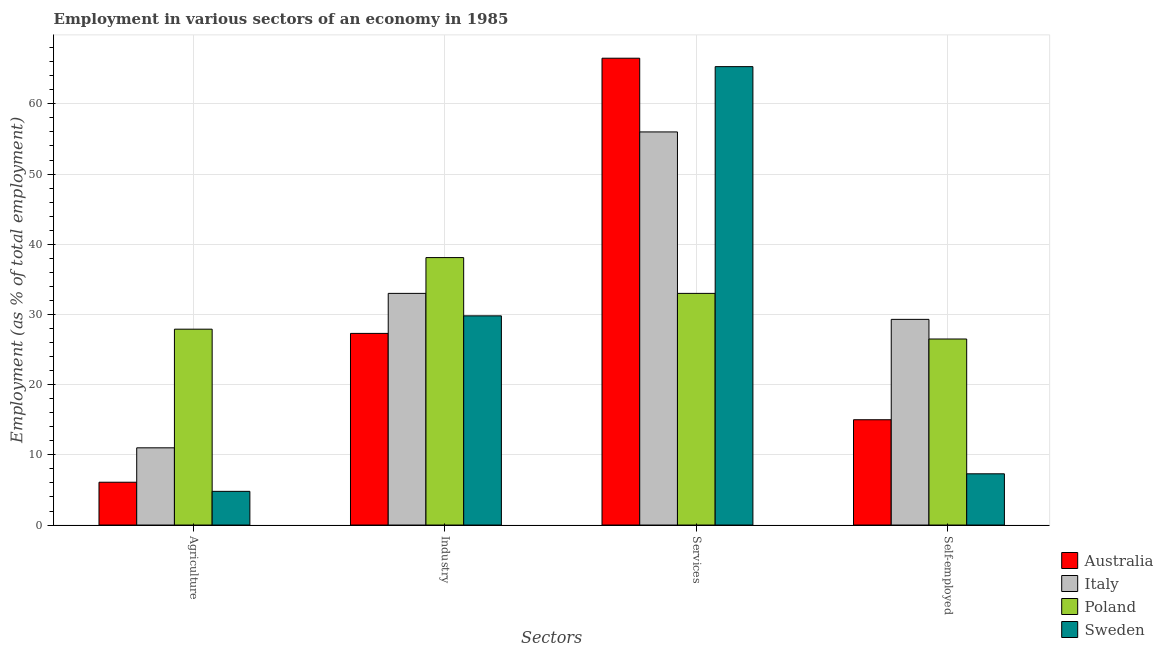How many bars are there on the 1st tick from the left?
Your answer should be compact. 4. How many bars are there on the 2nd tick from the right?
Your answer should be compact. 4. What is the label of the 4th group of bars from the left?
Give a very brief answer. Self-employed. What is the percentage of workers in services in Sweden?
Make the answer very short. 65.3. Across all countries, what is the maximum percentage of workers in industry?
Ensure brevity in your answer.  38.1. Across all countries, what is the minimum percentage of workers in industry?
Provide a short and direct response. 27.3. In which country was the percentage of workers in industry minimum?
Keep it short and to the point. Australia. What is the total percentage of workers in services in the graph?
Ensure brevity in your answer.  220.8. What is the difference between the percentage of workers in services in Australia and that in Sweden?
Make the answer very short. 1.2. What is the difference between the percentage of workers in agriculture in Poland and the percentage of self employed workers in Australia?
Keep it short and to the point. 12.9. What is the average percentage of workers in industry per country?
Ensure brevity in your answer.  32.05. What is the difference between the percentage of self employed workers and percentage of workers in agriculture in Italy?
Your answer should be compact. 18.3. In how many countries, is the percentage of workers in industry greater than 64 %?
Offer a terse response. 0. What is the ratio of the percentage of self employed workers in Sweden to that in Australia?
Keep it short and to the point. 0.49. Is the percentage of workers in agriculture in Australia less than that in Poland?
Your response must be concise. Yes. Is the difference between the percentage of workers in services in Italy and Australia greater than the difference between the percentage of workers in agriculture in Italy and Australia?
Offer a terse response. No. What is the difference between the highest and the second highest percentage of workers in industry?
Make the answer very short. 5.1. What is the difference between the highest and the lowest percentage of workers in industry?
Your response must be concise. 10.8. Is the sum of the percentage of workers in services in Sweden and Australia greater than the maximum percentage of workers in agriculture across all countries?
Your response must be concise. Yes. What does the 4th bar from the right in Agriculture represents?
Your response must be concise. Australia. Is it the case that in every country, the sum of the percentage of workers in agriculture and percentage of workers in industry is greater than the percentage of workers in services?
Provide a succinct answer. No. How many bars are there?
Your answer should be compact. 16. Are all the bars in the graph horizontal?
Provide a short and direct response. No. How many countries are there in the graph?
Keep it short and to the point. 4. Does the graph contain grids?
Provide a succinct answer. Yes. How are the legend labels stacked?
Your response must be concise. Vertical. What is the title of the graph?
Offer a very short reply. Employment in various sectors of an economy in 1985. Does "Cote d'Ivoire" appear as one of the legend labels in the graph?
Provide a succinct answer. No. What is the label or title of the X-axis?
Your answer should be very brief. Sectors. What is the label or title of the Y-axis?
Your response must be concise. Employment (as % of total employment). What is the Employment (as % of total employment) of Australia in Agriculture?
Ensure brevity in your answer.  6.1. What is the Employment (as % of total employment) in Italy in Agriculture?
Ensure brevity in your answer.  11. What is the Employment (as % of total employment) of Poland in Agriculture?
Make the answer very short. 27.9. What is the Employment (as % of total employment) of Sweden in Agriculture?
Provide a short and direct response. 4.8. What is the Employment (as % of total employment) of Australia in Industry?
Your answer should be compact. 27.3. What is the Employment (as % of total employment) in Italy in Industry?
Provide a short and direct response. 33. What is the Employment (as % of total employment) in Poland in Industry?
Give a very brief answer. 38.1. What is the Employment (as % of total employment) of Sweden in Industry?
Make the answer very short. 29.8. What is the Employment (as % of total employment) of Australia in Services?
Provide a succinct answer. 66.5. What is the Employment (as % of total employment) of Italy in Services?
Offer a terse response. 56. What is the Employment (as % of total employment) of Sweden in Services?
Provide a succinct answer. 65.3. What is the Employment (as % of total employment) in Australia in Self-employed?
Provide a short and direct response. 15. What is the Employment (as % of total employment) of Italy in Self-employed?
Ensure brevity in your answer.  29.3. What is the Employment (as % of total employment) of Sweden in Self-employed?
Provide a short and direct response. 7.3. Across all Sectors, what is the maximum Employment (as % of total employment) in Australia?
Your answer should be very brief. 66.5. Across all Sectors, what is the maximum Employment (as % of total employment) of Poland?
Offer a very short reply. 38.1. Across all Sectors, what is the maximum Employment (as % of total employment) in Sweden?
Offer a very short reply. 65.3. Across all Sectors, what is the minimum Employment (as % of total employment) in Australia?
Provide a short and direct response. 6.1. Across all Sectors, what is the minimum Employment (as % of total employment) of Sweden?
Your answer should be compact. 4.8. What is the total Employment (as % of total employment) of Australia in the graph?
Offer a very short reply. 114.9. What is the total Employment (as % of total employment) of Italy in the graph?
Your answer should be very brief. 129.3. What is the total Employment (as % of total employment) in Poland in the graph?
Give a very brief answer. 125.5. What is the total Employment (as % of total employment) of Sweden in the graph?
Provide a short and direct response. 107.2. What is the difference between the Employment (as % of total employment) of Australia in Agriculture and that in Industry?
Provide a succinct answer. -21.2. What is the difference between the Employment (as % of total employment) of Sweden in Agriculture and that in Industry?
Give a very brief answer. -25. What is the difference between the Employment (as % of total employment) of Australia in Agriculture and that in Services?
Your answer should be compact. -60.4. What is the difference between the Employment (as % of total employment) in Italy in Agriculture and that in Services?
Provide a short and direct response. -45. What is the difference between the Employment (as % of total employment) in Poland in Agriculture and that in Services?
Offer a terse response. -5.1. What is the difference between the Employment (as % of total employment) in Sweden in Agriculture and that in Services?
Make the answer very short. -60.5. What is the difference between the Employment (as % of total employment) in Australia in Agriculture and that in Self-employed?
Provide a short and direct response. -8.9. What is the difference between the Employment (as % of total employment) of Italy in Agriculture and that in Self-employed?
Offer a very short reply. -18.3. What is the difference between the Employment (as % of total employment) in Australia in Industry and that in Services?
Your answer should be compact. -39.2. What is the difference between the Employment (as % of total employment) in Italy in Industry and that in Services?
Offer a terse response. -23. What is the difference between the Employment (as % of total employment) of Sweden in Industry and that in Services?
Provide a short and direct response. -35.5. What is the difference between the Employment (as % of total employment) in Australia in Industry and that in Self-employed?
Offer a terse response. 12.3. What is the difference between the Employment (as % of total employment) in Poland in Industry and that in Self-employed?
Provide a succinct answer. 11.6. What is the difference between the Employment (as % of total employment) of Sweden in Industry and that in Self-employed?
Give a very brief answer. 22.5. What is the difference between the Employment (as % of total employment) in Australia in Services and that in Self-employed?
Ensure brevity in your answer.  51.5. What is the difference between the Employment (as % of total employment) in Italy in Services and that in Self-employed?
Give a very brief answer. 26.7. What is the difference between the Employment (as % of total employment) in Australia in Agriculture and the Employment (as % of total employment) in Italy in Industry?
Provide a succinct answer. -26.9. What is the difference between the Employment (as % of total employment) of Australia in Agriculture and the Employment (as % of total employment) of Poland in Industry?
Provide a succinct answer. -32. What is the difference between the Employment (as % of total employment) in Australia in Agriculture and the Employment (as % of total employment) in Sweden in Industry?
Your answer should be compact. -23.7. What is the difference between the Employment (as % of total employment) of Italy in Agriculture and the Employment (as % of total employment) of Poland in Industry?
Provide a short and direct response. -27.1. What is the difference between the Employment (as % of total employment) of Italy in Agriculture and the Employment (as % of total employment) of Sweden in Industry?
Your answer should be very brief. -18.8. What is the difference between the Employment (as % of total employment) of Poland in Agriculture and the Employment (as % of total employment) of Sweden in Industry?
Ensure brevity in your answer.  -1.9. What is the difference between the Employment (as % of total employment) in Australia in Agriculture and the Employment (as % of total employment) in Italy in Services?
Provide a succinct answer. -49.9. What is the difference between the Employment (as % of total employment) in Australia in Agriculture and the Employment (as % of total employment) in Poland in Services?
Offer a terse response. -26.9. What is the difference between the Employment (as % of total employment) in Australia in Agriculture and the Employment (as % of total employment) in Sweden in Services?
Your answer should be compact. -59.2. What is the difference between the Employment (as % of total employment) in Italy in Agriculture and the Employment (as % of total employment) in Sweden in Services?
Offer a very short reply. -54.3. What is the difference between the Employment (as % of total employment) of Poland in Agriculture and the Employment (as % of total employment) of Sweden in Services?
Provide a short and direct response. -37.4. What is the difference between the Employment (as % of total employment) of Australia in Agriculture and the Employment (as % of total employment) of Italy in Self-employed?
Provide a succinct answer. -23.2. What is the difference between the Employment (as % of total employment) of Australia in Agriculture and the Employment (as % of total employment) of Poland in Self-employed?
Keep it short and to the point. -20.4. What is the difference between the Employment (as % of total employment) in Australia in Agriculture and the Employment (as % of total employment) in Sweden in Self-employed?
Provide a succinct answer. -1.2. What is the difference between the Employment (as % of total employment) of Italy in Agriculture and the Employment (as % of total employment) of Poland in Self-employed?
Your answer should be very brief. -15.5. What is the difference between the Employment (as % of total employment) in Poland in Agriculture and the Employment (as % of total employment) in Sweden in Self-employed?
Offer a very short reply. 20.6. What is the difference between the Employment (as % of total employment) in Australia in Industry and the Employment (as % of total employment) in Italy in Services?
Offer a terse response. -28.7. What is the difference between the Employment (as % of total employment) in Australia in Industry and the Employment (as % of total employment) in Sweden in Services?
Ensure brevity in your answer.  -38. What is the difference between the Employment (as % of total employment) in Italy in Industry and the Employment (as % of total employment) in Poland in Services?
Your answer should be very brief. 0. What is the difference between the Employment (as % of total employment) in Italy in Industry and the Employment (as % of total employment) in Sweden in Services?
Offer a terse response. -32.3. What is the difference between the Employment (as % of total employment) of Poland in Industry and the Employment (as % of total employment) of Sweden in Services?
Offer a terse response. -27.2. What is the difference between the Employment (as % of total employment) in Italy in Industry and the Employment (as % of total employment) in Sweden in Self-employed?
Your answer should be compact. 25.7. What is the difference between the Employment (as % of total employment) of Poland in Industry and the Employment (as % of total employment) of Sweden in Self-employed?
Keep it short and to the point. 30.8. What is the difference between the Employment (as % of total employment) in Australia in Services and the Employment (as % of total employment) in Italy in Self-employed?
Your response must be concise. 37.2. What is the difference between the Employment (as % of total employment) of Australia in Services and the Employment (as % of total employment) of Sweden in Self-employed?
Keep it short and to the point. 59.2. What is the difference between the Employment (as % of total employment) of Italy in Services and the Employment (as % of total employment) of Poland in Self-employed?
Offer a terse response. 29.5. What is the difference between the Employment (as % of total employment) of Italy in Services and the Employment (as % of total employment) of Sweden in Self-employed?
Offer a terse response. 48.7. What is the difference between the Employment (as % of total employment) of Poland in Services and the Employment (as % of total employment) of Sweden in Self-employed?
Your response must be concise. 25.7. What is the average Employment (as % of total employment) in Australia per Sectors?
Offer a very short reply. 28.73. What is the average Employment (as % of total employment) in Italy per Sectors?
Your answer should be compact. 32.33. What is the average Employment (as % of total employment) of Poland per Sectors?
Ensure brevity in your answer.  31.38. What is the average Employment (as % of total employment) of Sweden per Sectors?
Offer a very short reply. 26.8. What is the difference between the Employment (as % of total employment) in Australia and Employment (as % of total employment) in Italy in Agriculture?
Keep it short and to the point. -4.9. What is the difference between the Employment (as % of total employment) of Australia and Employment (as % of total employment) of Poland in Agriculture?
Keep it short and to the point. -21.8. What is the difference between the Employment (as % of total employment) in Australia and Employment (as % of total employment) in Sweden in Agriculture?
Give a very brief answer. 1.3. What is the difference between the Employment (as % of total employment) in Italy and Employment (as % of total employment) in Poland in Agriculture?
Offer a very short reply. -16.9. What is the difference between the Employment (as % of total employment) in Poland and Employment (as % of total employment) in Sweden in Agriculture?
Your response must be concise. 23.1. What is the difference between the Employment (as % of total employment) of Australia and Employment (as % of total employment) of Italy in Industry?
Your answer should be compact. -5.7. What is the difference between the Employment (as % of total employment) of Australia and Employment (as % of total employment) of Poland in Industry?
Your answer should be very brief. -10.8. What is the difference between the Employment (as % of total employment) of Australia and Employment (as % of total employment) of Poland in Services?
Your response must be concise. 33.5. What is the difference between the Employment (as % of total employment) of Italy and Employment (as % of total employment) of Poland in Services?
Your answer should be compact. 23. What is the difference between the Employment (as % of total employment) in Italy and Employment (as % of total employment) in Sweden in Services?
Your response must be concise. -9.3. What is the difference between the Employment (as % of total employment) in Poland and Employment (as % of total employment) in Sweden in Services?
Offer a very short reply. -32.3. What is the difference between the Employment (as % of total employment) of Australia and Employment (as % of total employment) of Italy in Self-employed?
Make the answer very short. -14.3. What is the difference between the Employment (as % of total employment) of Australia and Employment (as % of total employment) of Poland in Self-employed?
Offer a very short reply. -11.5. What is the difference between the Employment (as % of total employment) of Australia and Employment (as % of total employment) of Sweden in Self-employed?
Keep it short and to the point. 7.7. What is the difference between the Employment (as % of total employment) of Italy and Employment (as % of total employment) of Poland in Self-employed?
Give a very brief answer. 2.8. What is the difference between the Employment (as % of total employment) of Italy and Employment (as % of total employment) of Sweden in Self-employed?
Ensure brevity in your answer.  22. What is the ratio of the Employment (as % of total employment) of Australia in Agriculture to that in Industry?
Your response must be concise. 0.22. What is the ratio of the Employment (as % of total employment) in Italy in Agriculture to that in Industry?
Your response must be concise. 0.33. What is the ratio of the Employment (as % of total employment) in Poland in Agriculture to that in Industry?
Your response must be concise. 0.73. What is the ratio of the Employment (as % of total employment) in Sweden in Agriculture to that in Industry?
Your response must be concise. 0.16. What is the ratio of the Employment (as % of total employment) of Australia in Agriculture to that in Services?
Ensure brevity in your answer.  0.09. What is the ratio of the Employment (as % of total employment) of Italy in Agriculture to that in Services?
Offer a very short reply. 0.2. What is the ratio of the Employment (as % of total employment) in Poland in Agriculture to that in Services?
Ensure brevity in your answer.  0.85. What is the ratio of the Employment (as % of total employment) of Sweden in Agriculture to that in Services?
Offer a terse response. 0.07. What is the ratio of the Employment (as % of total employment) in Australia in Agriculture to that in Self-employed?
Your response must be concise. 0.41. What is the ratio of the Employment (as % of total employment) of Italy in Agriculture to that in Self-employed?
Offer a terse response. 0.38. What is the ratio of the Employment (as % of total employment) in Poland in Agriculture to that in Self-employed?
Offer a terse response. 1.05. What is the ratio of the Employment (as % of total employment) in Sweden in Agriculture to that in Self-employed?
Provide a succinct answer. 0.66. What is the ratio of the Employment (as % of total employment) in Australia in Industry to that in Services?
Give a very brief answer. 0.41. What is the ratio of the Employment (as % of total employment) in Italy in Industry to that in Services?
Offer a terse response. 0.59. What is the ratio of the Employment (as % of total employment) of Poland in Industry to that in Services?
Give a very brief answer. 1.15. What is the ratio of the Employment (as % of total employment) in Sweden in Industry to that in Services?
Provide a succinct answer. 0.46. What is the ratio of the Employment (as % of total employment) of Australia in Industry to that in Self-employed?
Your response must be concise. 1.82. What is the ratio of the Employment (as % of total employment) of Italy in Industry to that in Self-employed?
Your answer should be very brief. 1.13. What is the ratio of the Employment (as % of total employment) of Poland in Industry to that in Self-employed?
Provide a succinct answer. 1.44. What is the ratio of the Employment (as % of total employment) of Sweden in Industry to that in Self-employed?
Keep it short and to the point. 4.08. What is the ratio of the Employment (as % of total employment) of Australia in Services to that in Self-employed?
Provide a short and direct response. 4.43. What is the ratio of the Employment (as % of total employment) in Italy in Services to that in Self-employed?
Offer a terse response. 1.91. What is the ratio of the Employment (as % of total employment) in Poland in Services to that in Self-employed?
Offer a terse response. 1.25. What is the ratio of the Employment (as % of total employment) in Sweden in Services to that in Self-employed?
Offer a terse response. 8.95. What is the difference between the highest and the second highest Employment (as % of total employment) of Australia?
Your answer should be very brief. 39.2. What is the difference between the highest and the second highest Employment (as % of total employment) in Italy?
Give a very brief answer. 23. What is the difference between the highest and the second highest Employment (as % of total employment) in Poland?
Offer a terse response. 5.1. What is the difference between the highest and the second highest Employment (as % of total employment) of Sweden?
Your answer should be compact. 35.5. What is the difference between the highest and the lowest Employment (as % of total employment) of Australia?
Keep it short and to the point. 60.4. What is the difference between the highest and the lowest Employment (as % of total employment) in Italy?
Your answer should be very brief. 45. What is the difference between the highest and the lowest Employment (as % of total employment) of Sweden?
Keep it short and to the point. 60.5. 